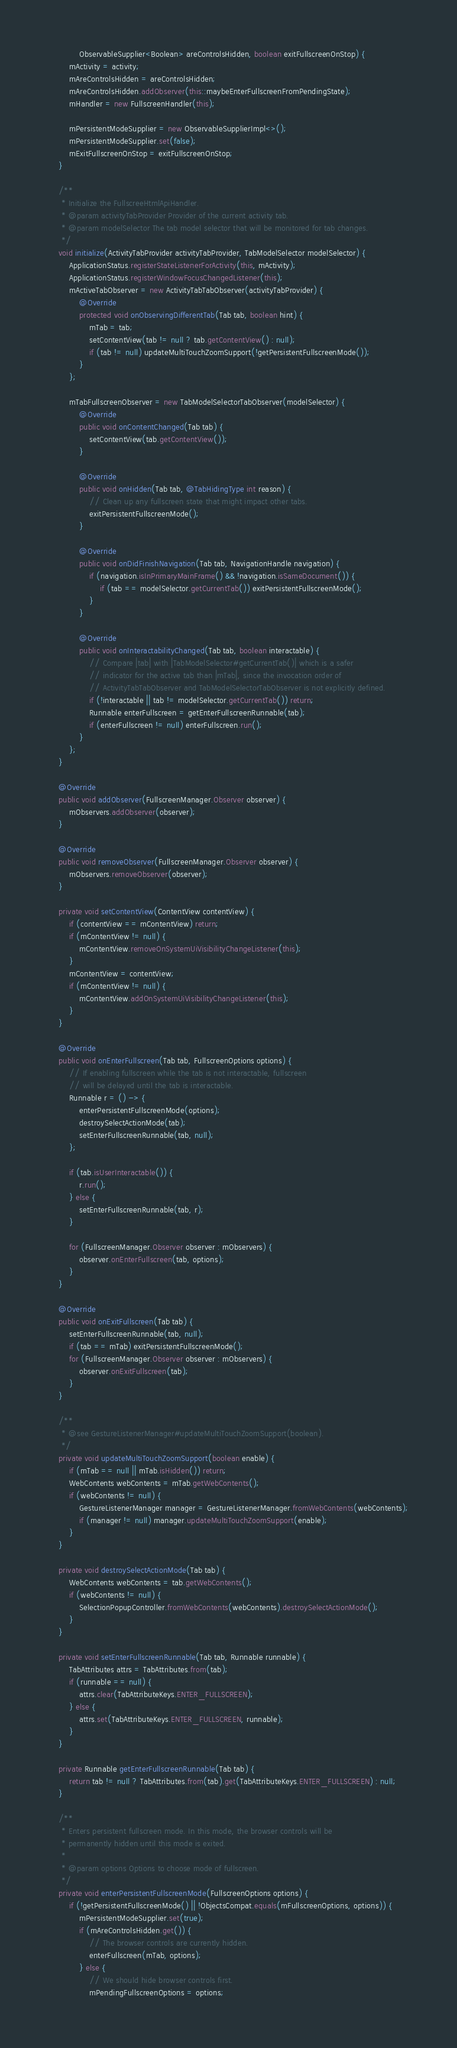<code> <loc_0><loc_0><loc_500><loc_500><_Java_>            ObservableSupplier<Boolean> areControlsHidden, boolean exitFullscreenOnStop) {
        mActivity = activity;
        mAreControlsHidden = areControlsHidden;
        mAreControlsHidden.addObserver(this::maybeEnterFullscreenFromPendingState);
        mHandler = new FullscreenHandler(this);

        mPersistentModeSupplier = new ObservableSupplierImpl<>();
        mPersistentModeSupplier.set(false);
        mExitFullscreenOnStop = exitFullscreenOnStop;
    }

    /**
     * Initialize the FullscreeHtmlApiHandler.
     * @param activityTabProvider Provider of the current activity tab.
     * @param modelSelector The tab model selector that will be monitored for tab changes.
     */
    void initialize(ActivityTabProvider activityTabProvider, TabModelSelector modelSelector) {
        ApplicationStatus.registerStateListenerForActivity(this, mActivity);
        ApplicationStatus.registerWindowFocusChangedListener(this);
        mActiveTabObserver = new ActivityTabTabObserver(activityTabProvider) {
            @Override
            protected void onObservingDifferentTab(Tab tab, boolean hint) {
                mTab = tab;
                setContentView(tab != null ? tab.getContentView() : null);
                if (tab != null) updateMultiTouchZoomSupport(!getPersistentFullscreenMode());
            }
        };

        mTabFullscreenObserver = new TabModelSelectorTabObserver(modelSelector) {
            @Override
            public void onContentChanged(Tab tab) {
                setContentView(tab.getContentView());
            }

            @Override
            public void onHidden(Tab tab, @TabHidingType int reason) {
                // Clean up any fullscreen state that might impact other tabs.
                exitPersistentFullscreenMode();
            }

            @Override
            public void onDidFinishNavigation(Tab tab, NavigationHandle navigation) {
                if (navigation.isInPrimaryMainFrame() && !navigation.isSameDocument()) {
                    if (tab == modelSelector.getCurrentTab()) exitPersistentFullscreenMode();
                }
            }

            @Override
            public void onInteractabilityChanged(Tab tab, boolean interactable) {
                // Compare |tab| with |TabModelSelector#getCurrentTab()| which is a safer
                // indicator for the active tab than |mTab|, since the invocation order of
                // ActivityTabTabObserver and TabModelSelectorTabObserver is not explicitly defined.
                if (!interactable || tab != modelSelector.getCurrentTab()) return;
                Runnable enterFullscreen = getEnterFullscreenRunnable(tab);
                if (enterFullscreen != null) enterFullscreen.run();
            }
        };
    }

    @Override
    public void addObserver(FullscreenManager.Observer observer) {
        mObservers.addObserver(observer);
    }

    @Override
    public void removeObserver(FullscreenManager.Observer observer) {
        mObservers.removeObserver(observer);
    }

    private void setContentView(ContentView contentView) {
        if (contentView == mContentView) return;
        if (mContentView != null) {
            mContentView.removeOnSystemUiVisibilityChangeListener(this);
        }
        mContentView = contentView;
        if (mContentView != null) {
            mContentView.addOnSystemUiVisibilityChangeListener(this);
        }
    }

    @Override
    public void onEnterFullscreen(Tab tab, FullscreenOptions options) {
        // If enabling fullscreen while the tab is not interactable, fullscreen
        // will be delayed until the tab is interactable.
        Runnable r = () -> {
            enterPersistentFullscreenMode(options);
            destroySelectActionMode(tab);
            setEnterFullscreenRunnable(tab, null);
        };

        if (tab.isUserInteractable()) {
            r.run();
        } else {
            setEnterFullscreenRunnable(tab, r);
        }

        for (FullscreenManager.Observer observer : mObservers) {
            observer.onEnterFullscreen(tab, options);
        }
    }

    @Override
    public void onExitFullscreen(Tab tab) {
        setEnterFullscreenRunnable(tab, null);
        if (tab == mTab) exitPersistentFullscreenMode();
        for (FullscreenManager.Observer observer : mObservers) {
            observer.onExitFullscreen(tab);
        }
    }

    /**
     * @see GestureListenerManager#updateMultiTouchZoomSupport(boolean).
     */
    private void updateMultiTouchZoomSupport(boolean enable) {
        if (mTab == null || mTab.isHidden()) return;
        WebContents webContents = mTab.getWebContents();
        if (webContents != null) {
            GestureListenerManager manager = GestureListenerManager.fromWebContents(webContents);
            if (manager != null) manager.updateMultiTouchZoomSupport(enable);
        }
    }

    private void destroySelectActionMode(Tab tab) {
        WebContents webContents = tab.getWebContents();
        if (webContents != null) {
            SelectionPopupController.fromWebContents(webContents).destroySelectActionMode();
        }
    }

    private void setEnterFullscreenRunnable(Tab tab, Runnable runnable) {
        TabAttributes attrs = TabAttributes.from(tab);
        if (runnable == null) {
            attrs.clear(TabAttributeKeys.ENTER_FULLSCREEN);
        } else {
            attrs.set(TabAttributeKeys.ENTER_FULLSCREEN, runnable);
        }
    }

    private Runnable getEnterFullscreenRunnable(Tab tab) {
        return tab != null ? TabAttributes.from(tab).get(TabAttributeKeys.ENTER_FULLSCREEN) : null;
    }

    /**
     * Enters persistent fullscreen mode. In this mode, the browser controls will be
     * permanently hidden until this mode is exited.
     *
     * @param options Options to choose mode of fullscreen.
     */
    private void enterPersistentFullscreenMode(FullscreenOptions options) {
        if (!getPersistentFullscreenMode() || !ObjectsCompat.equals(mFullscreenOptions, options)) {
            mPersistentModeSupplier.set(true);
            if (mAreControlsHidden.get()) {
                // The browser controls are currently hidden.
                enterFullscreen(mTab, options);
            } else {
                // We should hide browser controls first.
                mPendingFullscreenOptions = options;</code> 